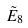Convert formula to latex. <formula><loc_0><loc_0><loc_500><loc_500>\tilde { E } _ { 8 }</formula> 